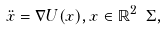Convert formula to latex. <formula><loc_0><loc_0><loc_500><loc_500>\ddot { x } = \nabla U ( x ) , x \in \mathbb { R } ^ { 2 } \ \Sigma ,</formula> 